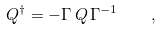Convert formula to latex. <formula><loc_0><loc_0><loc_500><loc_500>Q ^ { \dagger } = - \Gamma \, Q \, \Gamma ^ { - 1 } \quad ,</formula> 